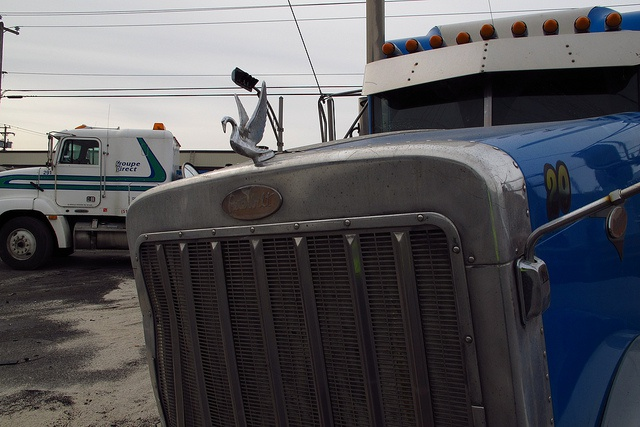Describe the objects in this image and their specific colors. I can see truck in black, lightgray, navy, gray, and darkgray tones and truck in lightgray, black, and gray tones in this image. 